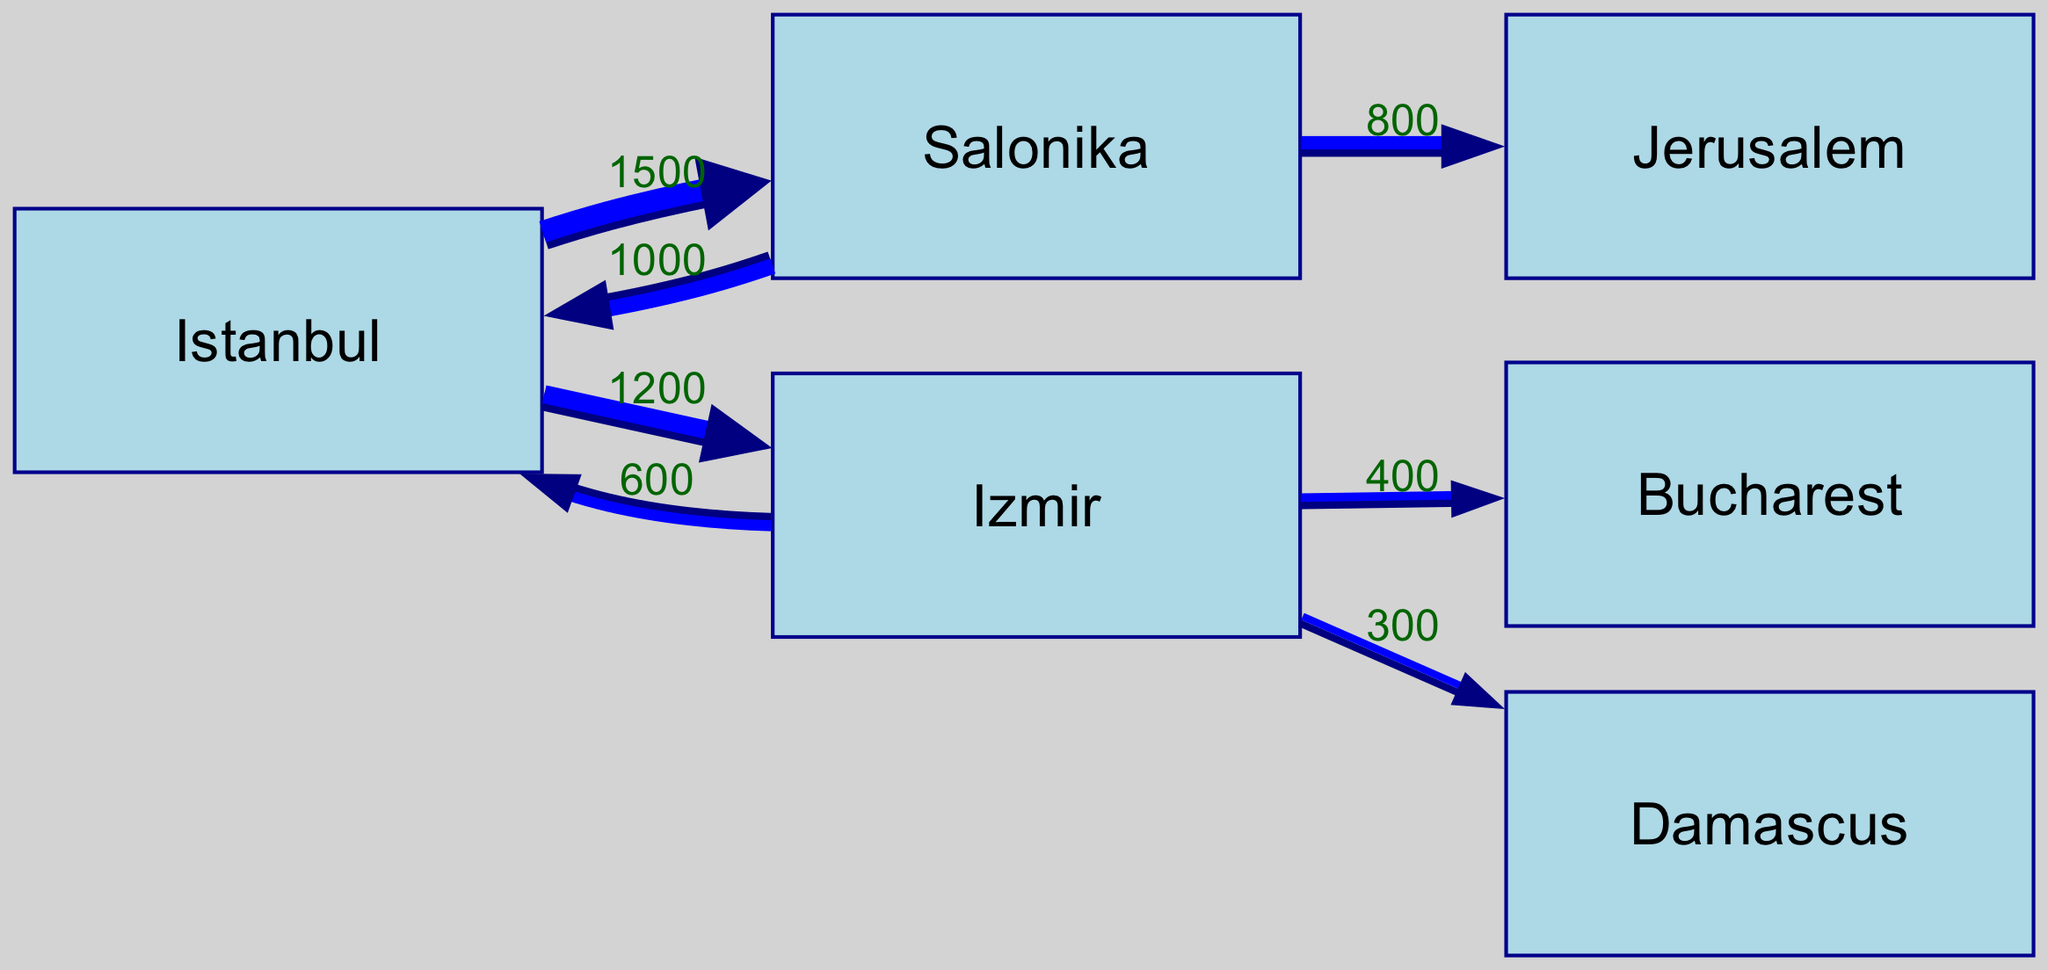What is the total number of nodes in the diagram? The diagram includes six nodes: Istanbul, Salonika, Izmir, Jerusalem, Bucharest, and Damascus. By counting them one by one, we determine the total number of unique locations represented.
Answer: 6 Which city has the highest outflow of Jewish populations based on the diagram? By examining the links originating from each node, we find that Istanbul has the largest outgoing flow, with a total of 2700 individuals migrating to Salonika and Izmir (1500 to Salonika + 1200 to Izmir). Thus, it shows the highest outflow of Jewish populations.
Answer: Istanbul What is the migration value from Salonika to Jerusalem? The diagram shows a direct link from Salonika to Jerusalem with a migration value of 800, indicating how many individuals moved from Salonika to Jerusalem.
Answer: 800 How many individuals migrated from Izmir to Bucharest? The diagram indicates a migration flow from Izmir to Bucharest with a value of 400 individuals, showcasing their movement from one city to another.
Answer: 400 Which relationship in the diagram has the lowest migration value? Evaluating all links, we observe that the smallest link is from Izmir to Damascus, which has a migration value of 300, highlighting the least active migration path.
Answer: 300 What is the total inflow of Jewish populations to Istanbul? To find this, we sum the incoming flows to Istanbul: 1000 from Salonika and 600 from Izmir, leading to a total inflow of 1600 individuals.
Answer: 1600 How many migrations are displayed in the diagram? The diagram contains a total of seven migration flows (links) between the various nodes, showcasing the different movement patterns of Jewish communities.
Answer: 7 Which city has a mutual migration relationship with Istanbul? The diagram shows a two-way migration flow between Istanbul and Salonika, as both cities have links connecting them, indicating mutual migration interactions.
Answer: Salonika What is the total outflow of Jewish communities from Izmir? By evaluating the outflows from Izmir, we see three migrations: 600 to Istanbul, 400 to Bucharest, and 300 to Damascus. Summing these gives a total outflow of 1300 individuals.
Answer: 1300 